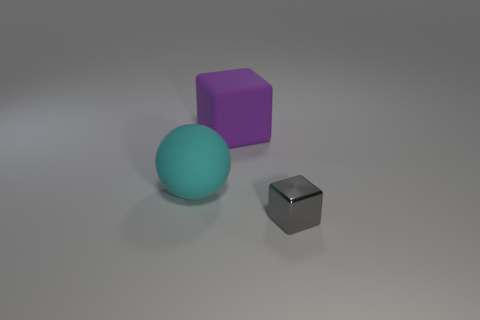Is there anything else that is made of the same material as the small block?
Give a very brief answer. No. What number of things are either small blue metallic things or large blocks that are behind the big cyan rubber object?
Give a very brief answer. 1. What color is the object that is to the left of the gray metallic cube and to the right of the cyan object?
Ensure brevity in your answer.  Purple. Do the rubber cube and the gray metal object have the same size?
Ensure brevity in your answer.  No. The block that is behind the small cube is what color?
Offer a terse response. Purple. The cube that is the same size as the cyan matte thing is what color?
Offer a terse response. Purple. Is the shape of the purple thing the same as the tiny gray shiny object?
Offer a very short reply. Yes. There is a thing behind the rubber ball; what is it made of?
Your answer should be very brief. Rubber. What is the color of the large matte cube?
Your answer should be compact. Purple. There is a block that is in front of the big block; is its size the same as the object that is to the left of the large purple cube?
Offer a terse response. No. 